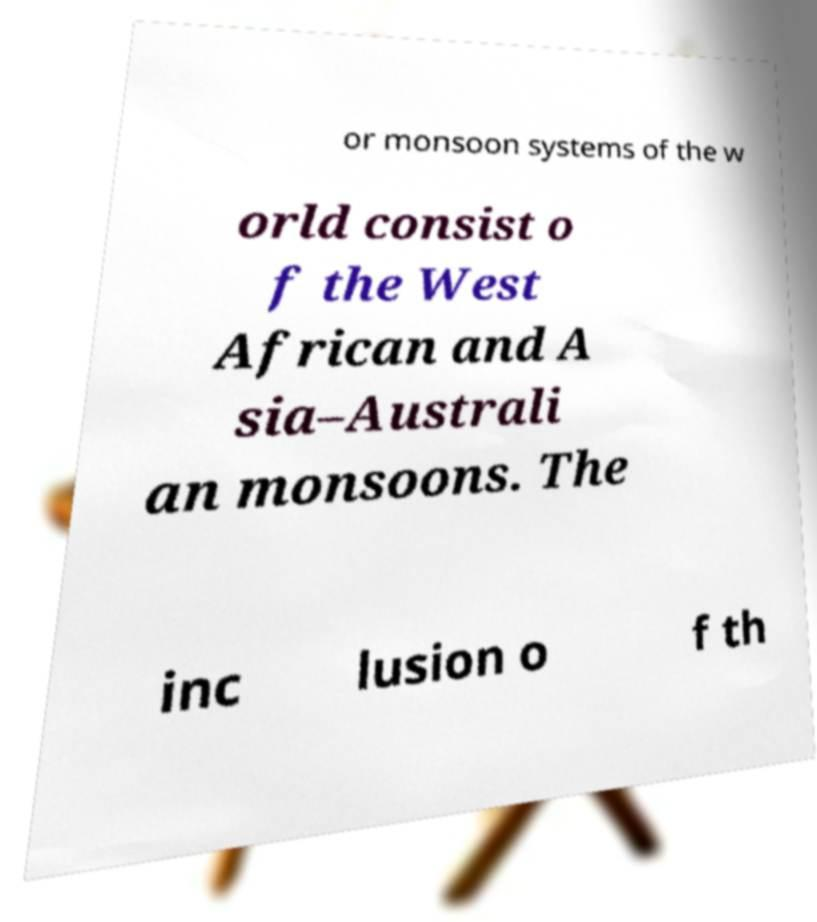For documentation purposes, I need the text within this image transcribed. Could you provide that? or monsoon systems of the w orld consist o f the West African and A sia–Australi an monsoons. The inc lusion o f th 